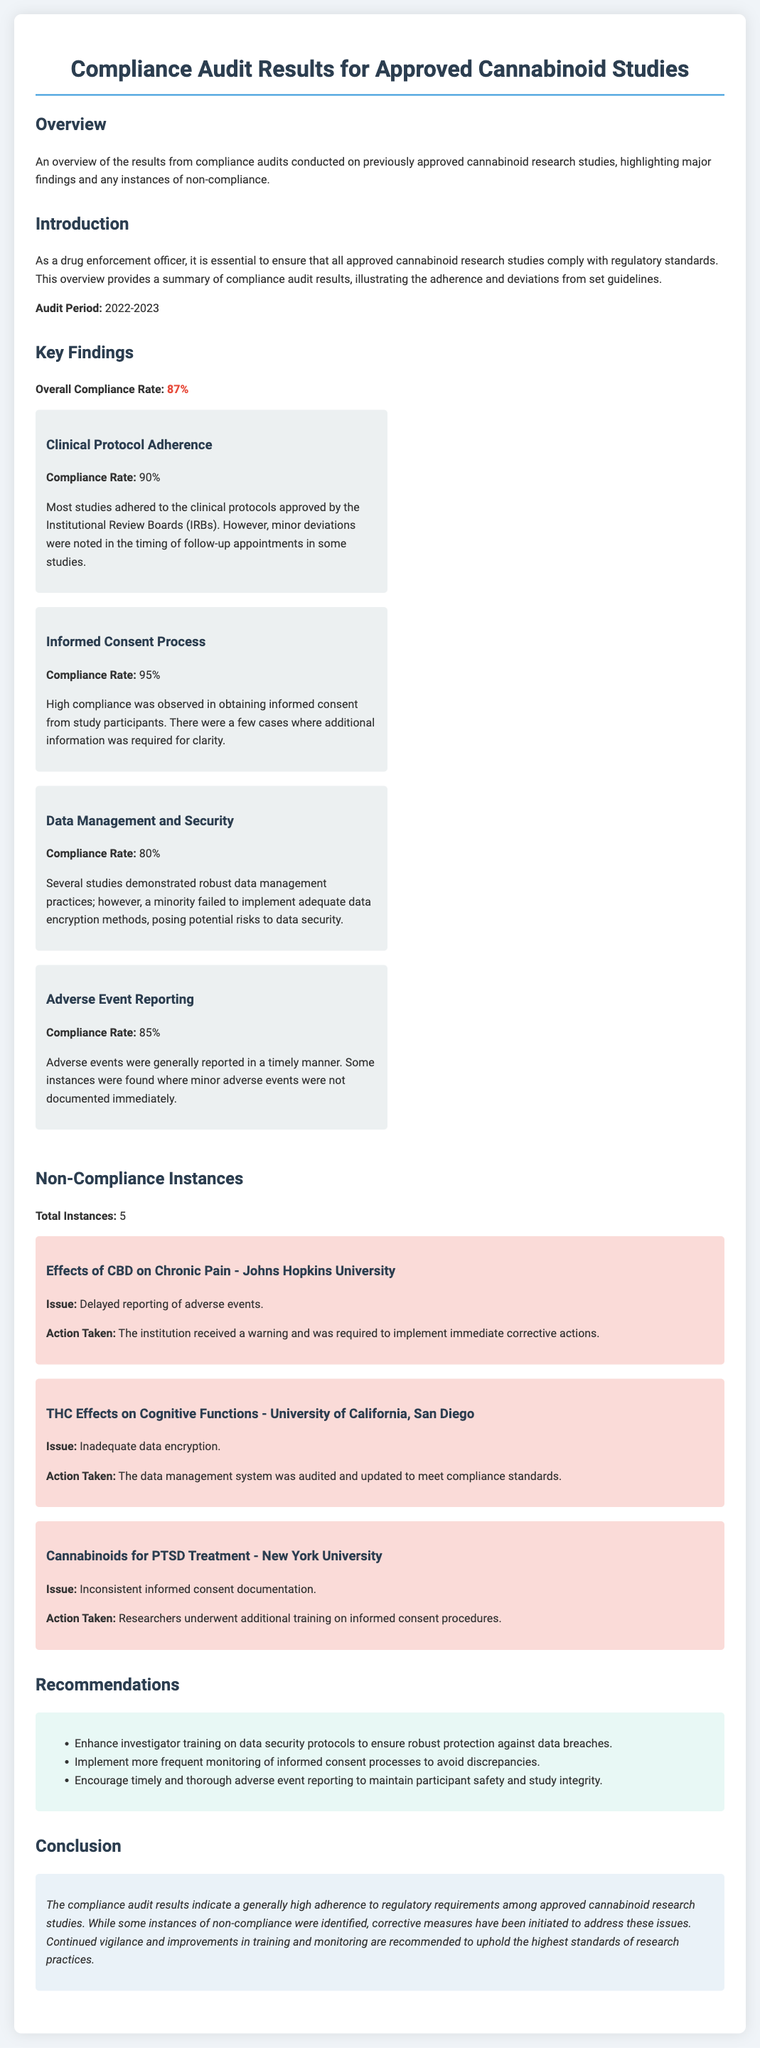What is the overall compliance rate? The overall compliance rate is stated in the document and is calculated based on the results of the compliance audits conducted.
Answer: 87% What was the audit period? The audit period is specified in the introduction section of the document, indicating the timeframe these audits covered.
Answer: 2022-2023 Which study had an issue with delayed reporting of adverse events? The non-compliance instance section lists the studies along with their specific issues, allowing for identification of the study related to reporting delays.
Answer: Effects of CBD on Chronic Pain - Johns Hopkins University How many total instances of non-compliance were reported? The document explicitly mentions the total number of non-compliance instances found during the audits.
Answer: 5 What is a recommendation provided in the document? The recommendations section lists several suggestions geared towards improving compliance, which provides insights into areas needing enhancement.
Answer: Enhance investigator training on data security protocols What was the compliance rate for informed consent processes? The document details compliance rates for several categories, including the specific rate for the informed consent process.
Answer: 95% What action was taken for inadequate data encryption? The action taken for this specific non-compliance issue is described in the context of a specific study’s findings.
Answer: The data management system was audited and updated to meet compliance standards What was the issue with the Cannabinoids for PTSD Treatment study? The non-compliance instance section details the issues faced by the study regarding compliance.
Answer: Inconsistent informed consent documentation 